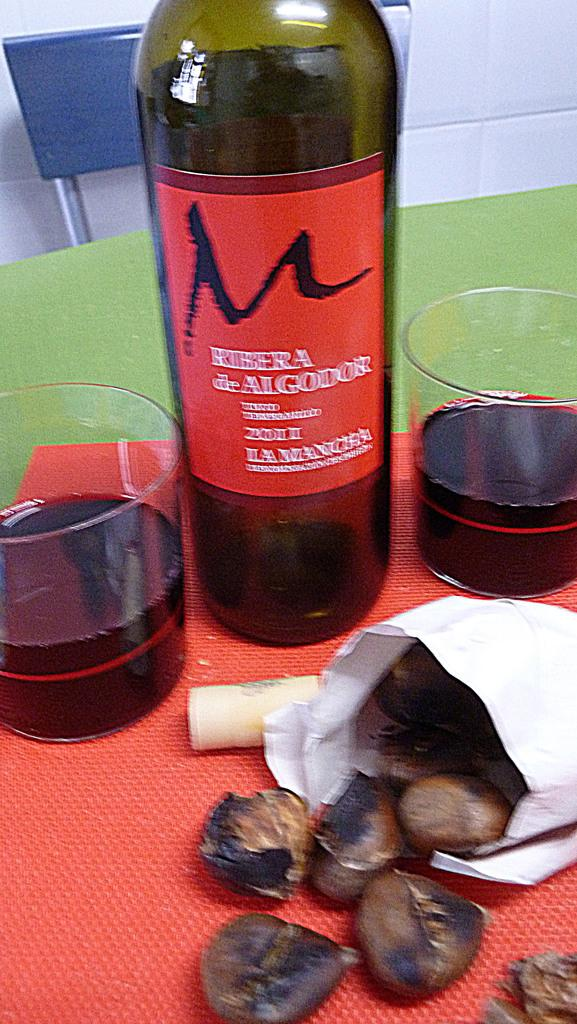What piece of furniture is present in the image? There is a table in the image. What is placed on the table? There is a wine bottle and a glass on the table. What else can be seen on the table? There is a paper with stuff on the table. Where is the shelf located in the image? There is no shelf present in the image. What type of rifle can be seen on the table? There is no rifle present in the image. 